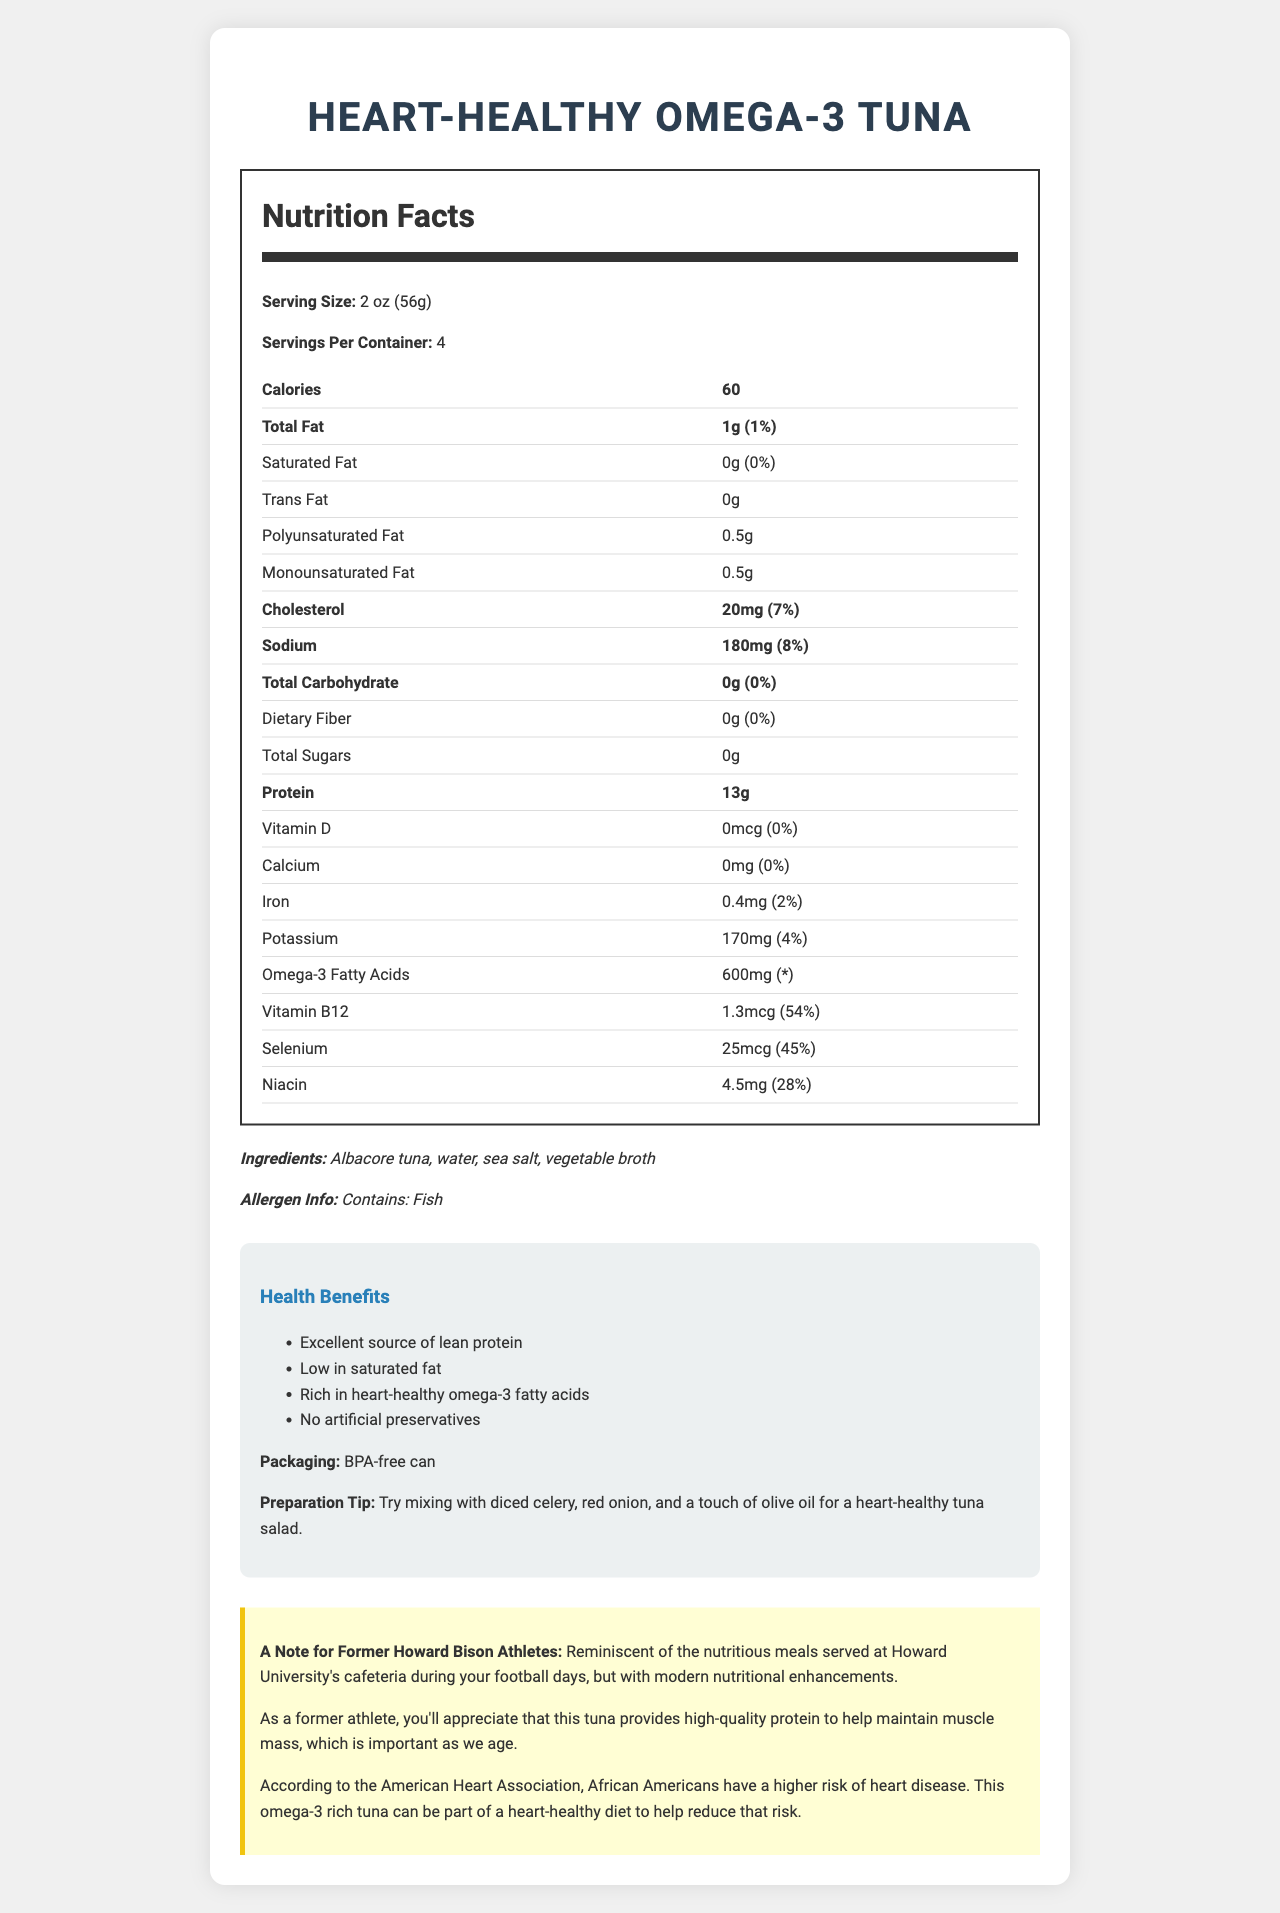what is the serving size? The serving size is explicitly mentioned in the document.
Answer: 2 oz (56g) how many servings are there per container? The number of servings per container is clearly indicated.
Answer: 4 how many calories are in one serving? The document specifies that there are 60 calories per serving.
Answer: 60 what percentage of the daily value for saturated fat is in one serving? The daily value percentage for saturated fat in one serving is indicated as 0%.
Answer: 0% what is the amount of omega-3 fatty acids per serving? The document lists 600mg of omega-3 fatty acids per serving.
Answer: 600mg which ingredient is not listed in the document? A. Albacore tuna B. Water C. Olive oil D. Sea salt Olive oil is not mentioned as an ingredient in the document.
Answer: C how much protein does one serving contain? A. 10g B. 12g C. 13g D. 15g The document shows 13g of protein per serving.
Answer: C is this product low in saturated fat? The document mentions that the product has 0g of saturated fat per serving, which qualifies it as low in saturated fat.
Answer: Yes does the product contain any artificial preservatives? The health claims section states there are no artificial preservatives.
Answer: No what is the total amount of cholesterol per serving, and its daily value percentage? The document specifies that each serving contains 20mg of cholesterol, accounting for 7% of the daily value.
Answer: 20mg, 7% can this document determine if this product is gluten-free? The document does not provide information regarding gluten content.
Answer: Cannot be determined how does this product benefit former athletes? The document notes that the product offers high-quality protein, which helps maintain muscle mass, beneficial for former athletes.
Answer: Provides high-quality protein to maintain muscle mass describe the main idea of the document. The document includes sections on nutrition facts, ingredients, health benefits, preparation tips, and tailored messages for African American heart health and former athletes.
Answer: The document provides detailed nutrition facts about the Heart-Healthy Omega-3 Tuna, highlighting its benefits, ingredients, health claims, and specific notes for African American heart health and former athletes. 